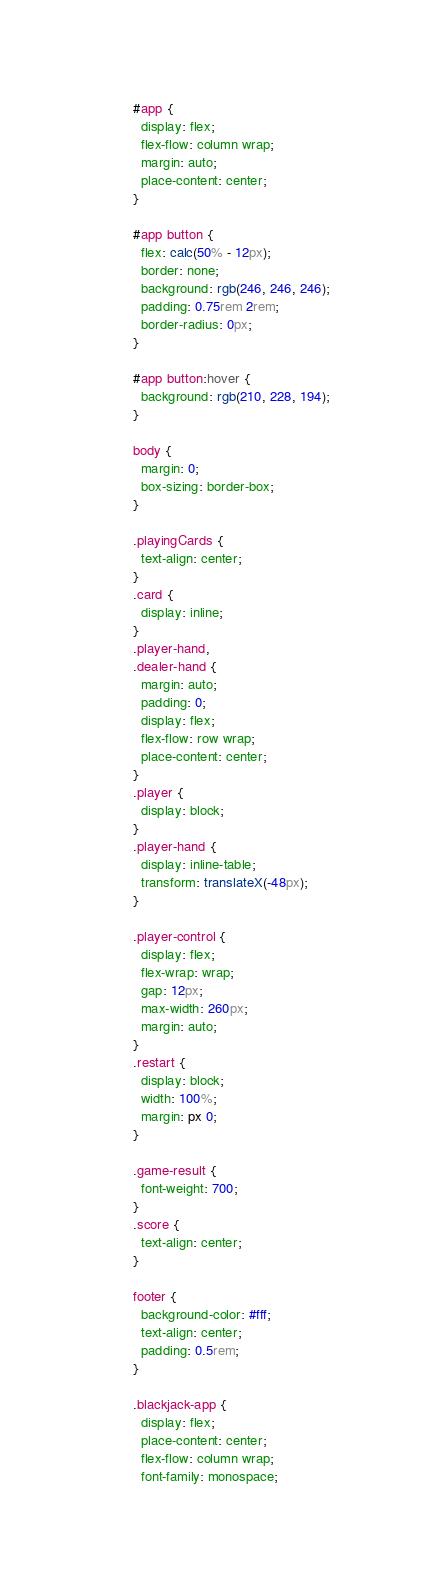Convert code to text. <code><loc_0><loc_0><loc_500><loc_500><_CSS_>#app {
  display: flex;
  flex-flow: column wrap;
  margin: auto;
  place-content: center;
}

#app button {
  flex: calc(50% - 12px);
  border: none;
  background: rgb(246, 246, 246);
  padding: 0.75rem 2rem;
  border-radius: 0px;
}

#app button:hover {
  background: rgb(210, 228, 194);
}

body {
  margin: 0;
  box-sizing: border-box;
}

.playingCards {
  text-align: center;
}
.card {
  display: inline;
}
.player-hand,
.dealer-hand {
  margin: auto;
  padding: 0;
  display: flex;
  flex-flow: row wrap;
  place-content: center;
}
.player {
  display: block;
}
.player-hand {
  display: inline-table;
  transform: translateX(-48px);
}

.player-control {
  display: flex;
  flex-wrap: wrap;
  gap: 12px;
  max-width: 260px;
  margin: auto;
}
.restart {
  display: block;
  width: 100%;
  margin: px 0;
}

.game-result {
  font-weight: 700;
}
.score {
  text-align: center;
}

footer {
  background-color: #fff;
  text-align: center;
  padding: 0.5rem;
}

.blackjack-app {
  display: flex;
  place-content: center;
  flex-flow: column wrap;
  font-family: monospace;</code> 